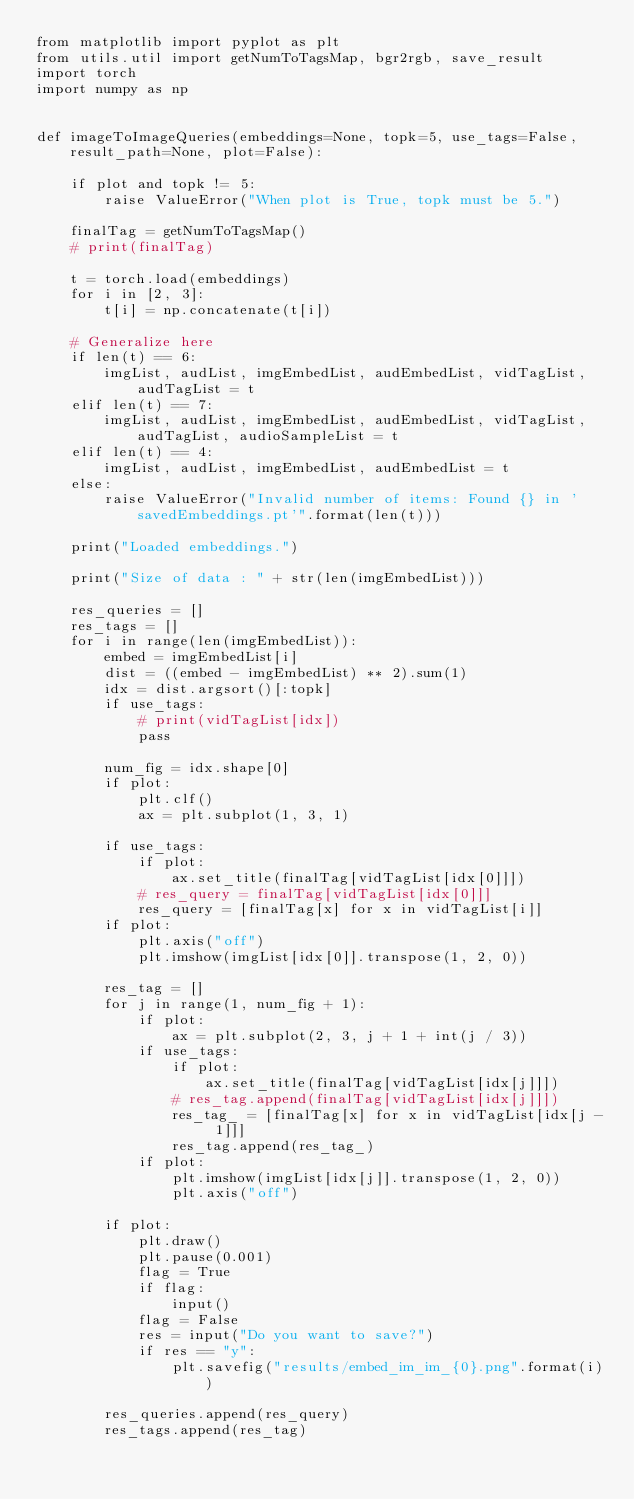Convert code to text. <code><loc_0><loc_0><loc_500><loc_500><_Python_>from matplotlib import pyplot as plt
from utils.util import getNumToTagsMap, bgr2rgb, save_result
import torch
import numpy as np


def imageToImageQueries(embeddings=None, topk=5, use_tags=False, result_path=None, plot=False):

    if plot and topk != 5:
        raise ValueError("When plot is True, topk must be 5.")

    finalTag = getNumToTagsMap()
    # print(finalTag)

    t = torch.load(embeddings)
    for i in [2, 3]:
        t[i] = np.concatenate(t[i])

    # Generalize here
    if len(t) == 6:
        imgList, audList, imgEmbedList, audEmbedList, vidTagList, audTagList = t
    elif len(t) == 7:
        imgList, audList, imgEmbedList, audEmbedList, vidTagList, audTagList, audioSampleList = t
    elif len(t) == 4:
        imgList, audList, imgEmbedList, audEmbedList = t
    else:
        raise ValueError("Invalid number of items: Found {} in 'savedEmbeddings.pt'".format(len(t)))

    print("Loaded embeddings.")

    print("Size of data : " + str(len(imgEmbedList)))

    res_queries = []
    res_tags = []
    for i in range(len(imgEmbedList)):
        embed = imgEmbedList[i]
        dist = ((embed - imgEmbedList) ** 2).sum(1)
        idx = dist.argsort()[:topk]
        if use_tags:
            # print(vidTagList[idx])
            pass

        num_fig = idx.shape[0]
        if plot:
            plt.clf()
            ax = plt.subplot(1, 3, 1)

        if use_tags:
            if plot:
                ax.set_title(finalTag[vidTagList[idx[0]]])
            # res_query = finalTag[vidTagList[idx[0]]]
            res_query = [finalTag[x] for x in vidTagList[i]]
        if plot:
            plt.axis("off")
            plt.imshow(imgList[idx[0]].transpose(1, 2, 0))

        res_tag = []
        for j in range(1, num_fig + 1):
            if plot:
                ax = plt.subplot(2, 3, j + 1 + int(j / 3))
            if use_tags:
                if plot:
                    ax.set_title(finalTag[vidTagList[idx[j]]])
                # res_tag.append(finalTag[vidTagList[idx[j]]])
                res_tag_ = [finalTag[x] for x in vidTagList[idx[j - 1]]]
                res_tag.append(res_tag_)
            if plot:
                plt.imshow(imgList[idx[j]].transpose(1, 2, 0))
                plt.axis("off")

        if plot:
            plt.draw()
            plt.pause(0.001)
            flag = True
            if flag:
                input()
            flag = False
            res = input("Do you want to save?")
            if res == "y":
                plt.savefig("results/embed_im_im_{0}.png".format(i))

        res_queries.append(res_query)
        res_tags.append(res_tag)</code> 